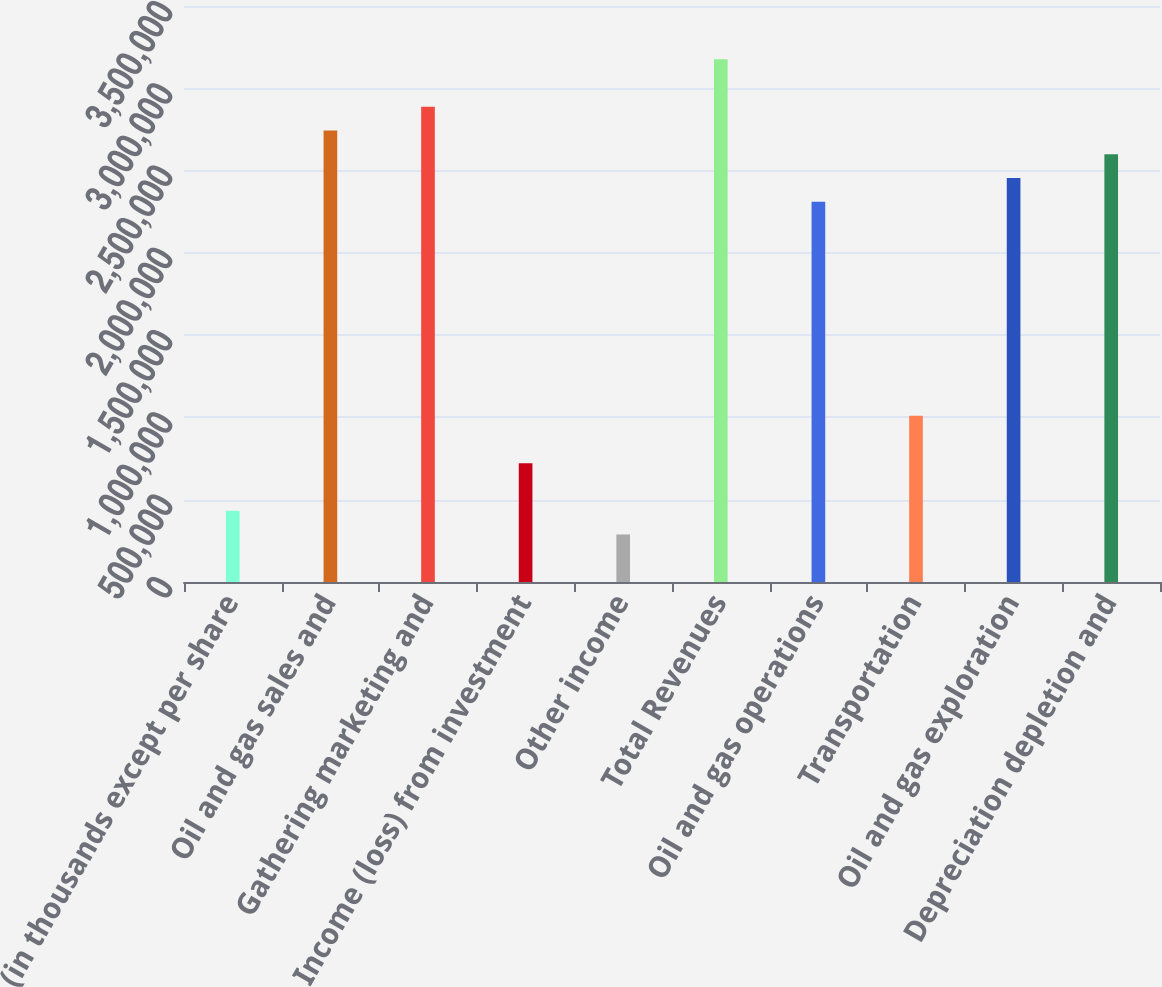Convert chart to OTSL. <chart><loc_0><loc_0><loc_500><loc_500><bar_chart><fcel>(in thousands except per share<fcel>Oil and gas sales and<fcel>Gathering marketing and<fcel>Income (loss) from investment<fcel>Other income<fcel>Total Revenues<fcel>Oil and gas operations<fcel>Transportation<fcel>Oil and gas exploration<fcel>Depreciation depletion and<nl><fcel>433119<fcel>2.74308e+06<fcel>2.88746e+06<fcel>721864<fcel>288746<fcel>3.1762e+06<fcel>2.30996e+06<fcel>1.01061e+06<fcel>2.45434e+06<fcel>2.59871e+06<nl></chart> 